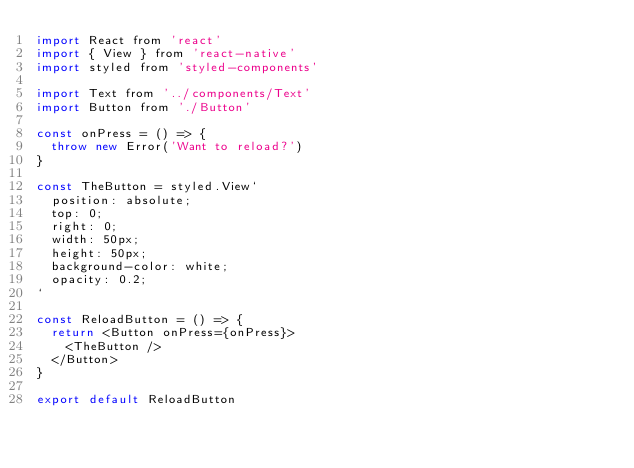Convert code to text. <code><loc_0><loc_0><loc_500><loc_500><_JavaScript_>import React from 'react'
import { View } from 'react-native'
import styled from 'styled-components'

import Text from '../components/Text'
import Button from './Button'

const onPress = () => {
  throw new Error('Want to reload?')
}

const TheButton = styled.View`
  position: absolute;
  top: 0;
  right: 0;
  width: 50px;
  height: 50px;
  background-color: white;
  opacity: 0.2;
`

const ReloadButton = () => {
  return <Button onPress={onPress}>
    <TheButton />
  </Button>
}

export default ReloadButton
</code> 